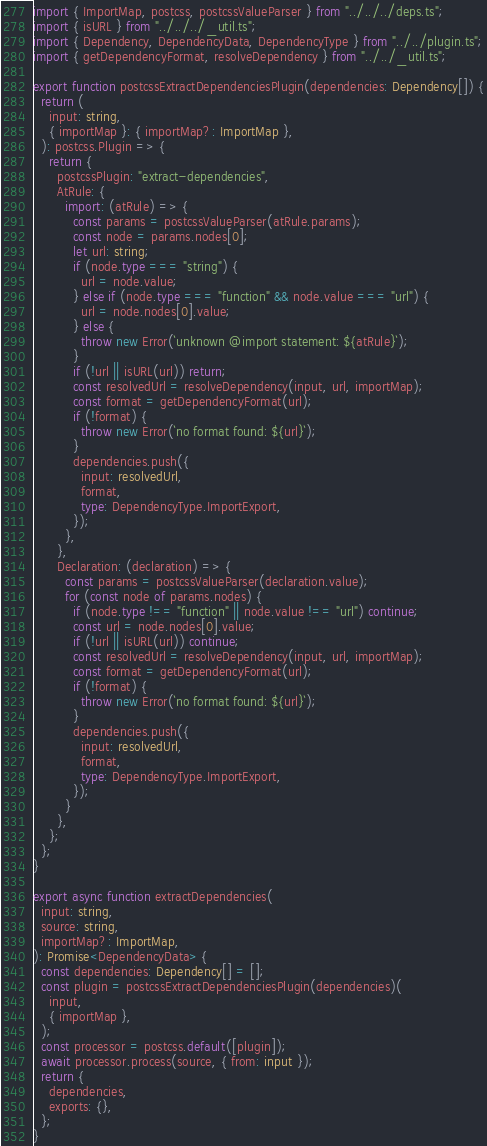Convert code to text. <code><loc_0><loc_0><loc_500><loc_500><_TypeScript_>import { ImportMap, postcss, postcssValueParser } from "../../../deps.ts";
import { isURL } from "../../../_util.ts";
import { Dependency, DependencyData, DependencyType } from "../../plugin.ts";
import { getDependencyFormat, resolveDependency } from "../../_util.ts";

export function postcssExtractDependenciesPlugin(dependencies: Dependency[]) {
  return (
    input: string,
    { importMap }: { importMap?: ImportMap },
  ): postcss.Plugin => {
    return {
      postcssPlugin: "extract-dependencies",
      AtRule: {
        import: (atRule) => {
          const params = postcssValueParser(atRule.params);
          const node = params.nodes[0];
          let url: string;
          if (node.type === "string") {
            url = node.value;
          } else if (node.type === "function" && node.value === "url") {
            url = node.nodes[0].value;
          } else {
            throw new Error(`unknown @import statement: ${atRule}`);
          }
          if (!url || isURL(url)) return;
          const resolvedUrl = resolveDependency(input, url, importMap);
          const format = getDependencyFormat(url);
          if (!format) {
            throw new Error(`no format found: ${url}`);
          }
          dependencies.push({
            input: resolvedUrl,
            format,
            type: DependencyType.ImportExport,
          });
        },
      },
      Declaration: (declaration) => {
        const params = postcssValueParser(declaration.value);
        for (const node of params.nodes) {
          if (node.type !== "function" || node.value !== "url") continue;
          const url = node.nodes[0].value;
          if (!url || isURL(url)) continue;
          const resolvedUrl = resolveDependency(input, url, importMap);
          const format = getDependencyFormat(url);
          if (!format) {
            throw new Error(`no format found: ${url}`);
          }
          dependencies.push({
            input: resolvedUrl,
            format,
            type: DependencyType.ImportExport,
          });
        }
      },
    };
  };
}

export async function extractDependencies(
  input: string,
  source: string,
  importMap?: ImportMap,
): Promise<DependencyData> {
  const dependencies: Dependency[] = [];
  const plugin = postcssExtractDependenciesPlugin(dependencies)(
    input,
    { importMap },
  );
  const processor = postcss.default([plugin]);
  await processor.process(source, { from: input });
  return {
    dependencies,
    exports: {},
  };
}
</code> 